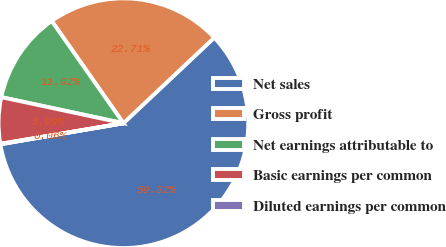Convert chart to OTSL. <chart><loc_0><loc_0><loc_500><loc_500><pie_chart><fcel>Net sales<fcel>Gross profit<fcel>Net earnings attributable to<fcel>Basic earnings per common<fcel>Diluted earnings per common<nl><fcel>59.32%<fcel>22.71%<fcel>11.92%<fcel>5.99%<fcel>0.06%<nl></chart> 